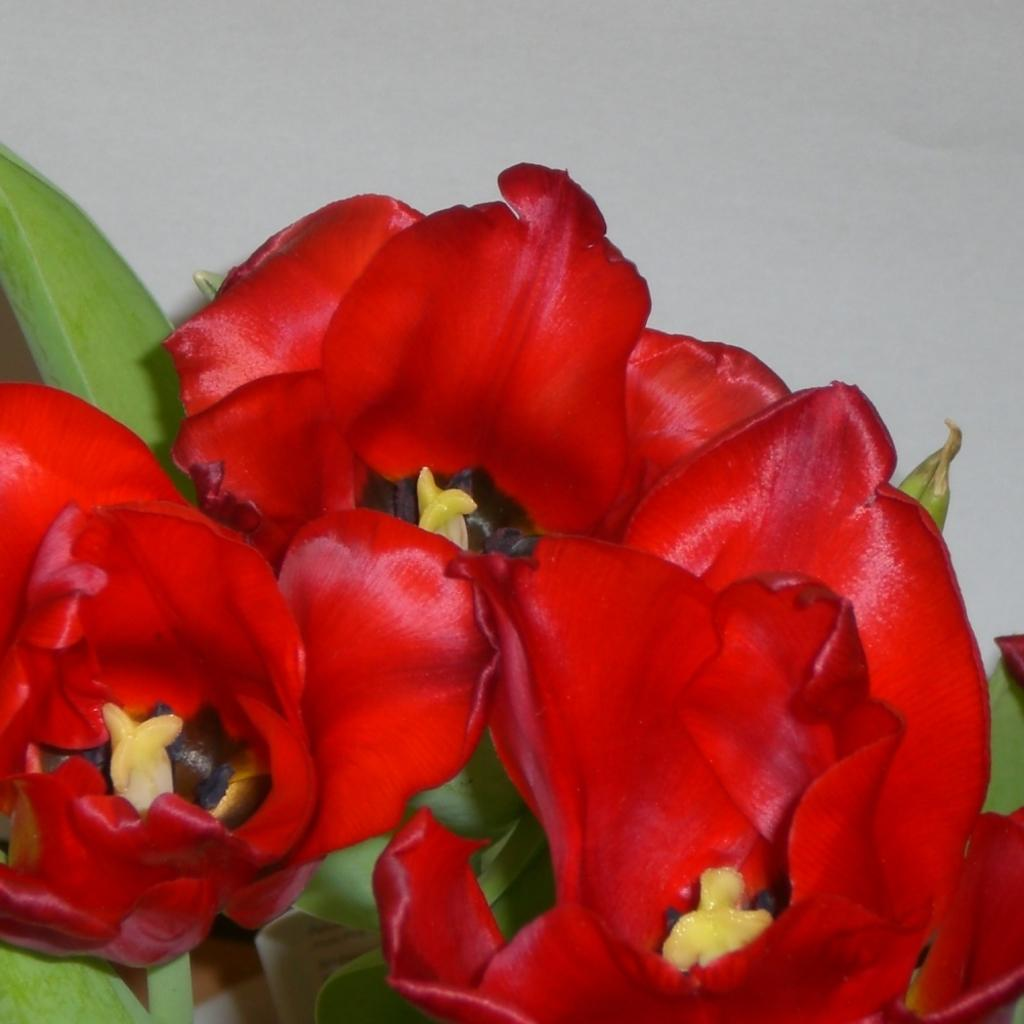What type of plants are in the image? There are flowers in the image. What color are the flowers? The flowers are red in color. Where are the flowers located in the image? The flowers are in the center of the image. What type of drain is visible in the image? There is no drain present in the image; it features red flowers in the center. 